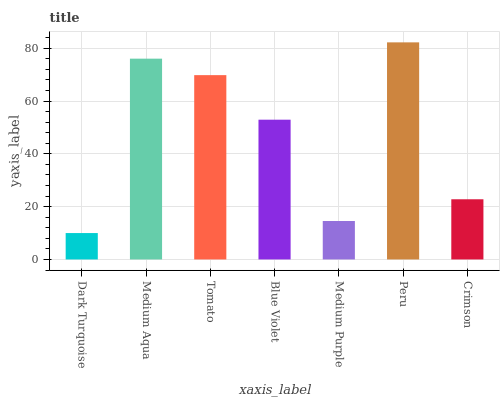Is Dark Turquoise the minimum?
Answer yes or no. Yes. Is Peru the maximum?
Answer yes or no. Yes. Is Medium Aqua the minimum?
Answer yes or no. No. Is Medium Aqua the maximum?
Answer yes or no. No. Is Medium Aqua greater than Dark Turquoise?
Answer yes or no. Yes. Is Dark Turquoise less than Medium Aqua?
Answer yes or no. Yes. Is Dark Turquoise greater than Medium Aqua?
Answer yes or no. No. Is Medium Aqua less than Dark Turquoise?
Answer yes or no. No. Is Blue Violet the high median?
Answer yes or no. Yes. Is Blue Violet the low median?
Answer yes or no. Yes. Is Medium Aqua the high median?
Answer yes or no. No. Is Medium Purple the low median?
Answer yes or no. No. 